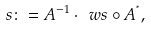Convert formula to latex. <formula><loc_0><loc_0><loc_500><loc_500>s \colon = A ^ { - 1 } \cdot \ w s \circ A ^ { ^ { * } } ,</formula> 